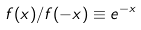<formula> <loc_0><loc_0><loc_500><loc_500>f ( x ) / f ( - x ) \equiv e ^ { - x }</formula> 